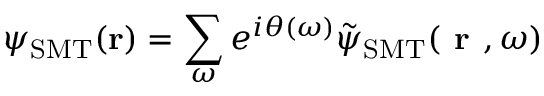<formula> <loc_0><loc_0><loc_500><loc_500>\psi _ { S M T } ( { r } ) = \sum _ { \omega } e ^ { i \theta ( \omega ) } \tilde { \psi } _ { S M T } ( r , \omega )</formula> 